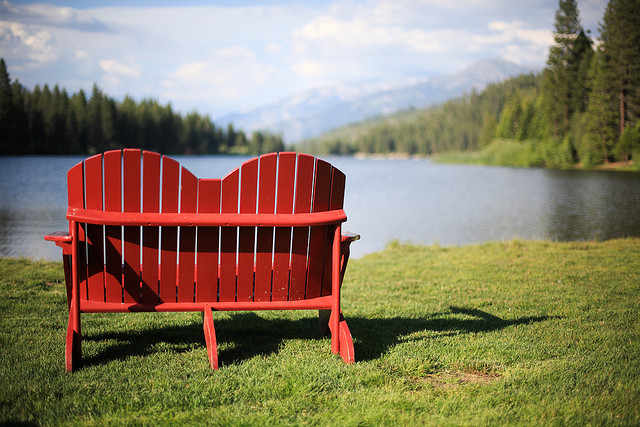If a family were to visit this site, what might their day look like? A family visiting this site would likely start their day with a leisurely breakfast by the lake, packing a picnic basket full of delicious treats. They'd then spend the morning exploring the hiking trails, with the kids excitedly pointing out different birds and plants they discover along the way. As the day warms up, they might rent a canoe for some fun on the water, paddling around and perhaps even trying a bit of fishing. After lunch, they could relax on the grassy shore, playing games or reading books while enjoying the peaceful surroundings. In the late afternoon, they'd gather on the red bench to watch the sunset, cherishing the beautiful memories made together in this magical place. 